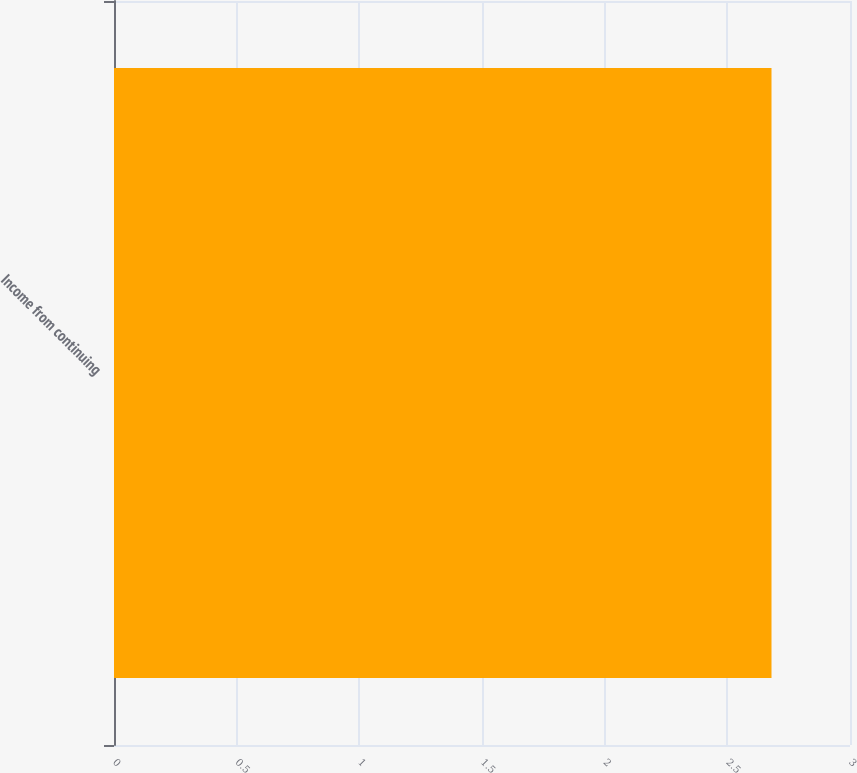<chart> <loc_0><loc_0><loc_500><loc_500><bar_chart><fcel>Income from continuing<nl><fcel>2.68<nl></chart> 